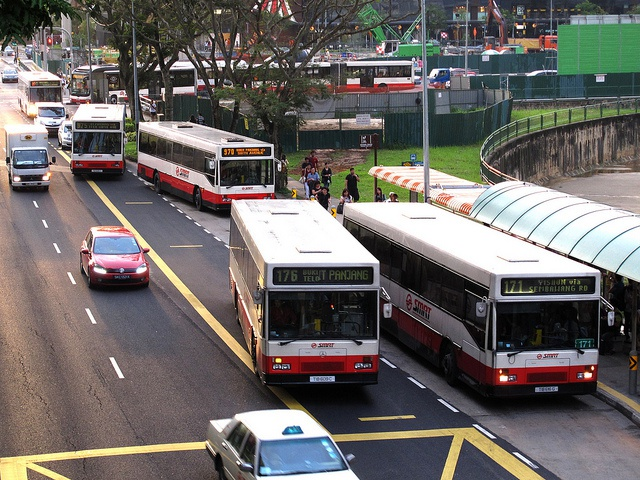Describe the objects in this image and their specific colors. I can see bus in black, white, darkgray, and gray tones, bus in black, white, darkgray, and gray tones, bus in black, lightgray, darkgray, and gray tones, car in black, white, darkgray, and gray tones, and bus in black, gray, lightgray, and darkgray tones in this image. 